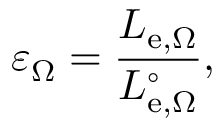Convert formula to latex. <formula><loc_0><loc_0><loc_500><loc_500>\varepsilon _ { \Omega } = { \frac { L _ { e , \Omega } } { L _ { e , \Omega } ^ { \circ } } } ,</formula> 